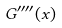<formula> <loc_0><loc_0><loc_500><loc_500>G ^ { \prime \prime \prime \prime } ( x )</formula> 